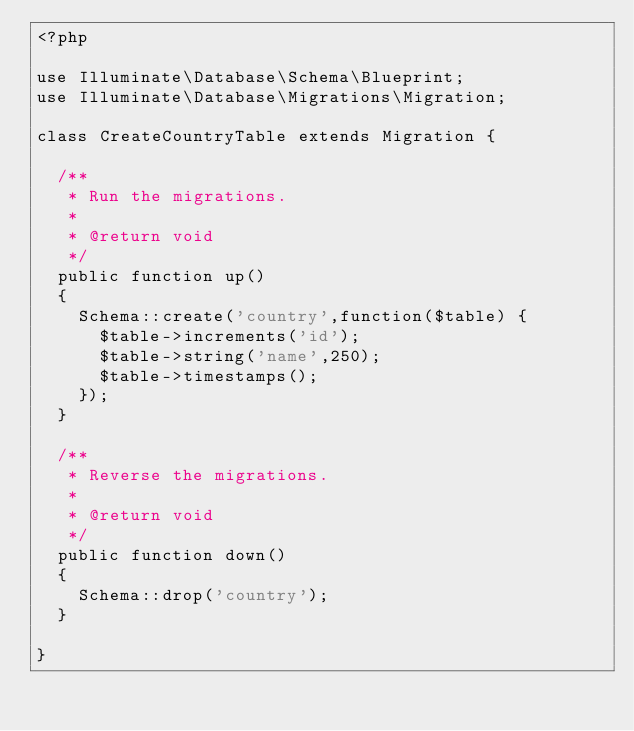Convert code to text. <code><loc_0><loc_0><loc_500><loc_500><_PHP_><?php

use Illuminate\Database\Schema\Blueprint;
use Illuminate\Database\Migrations\Migration;

class CreateCountryTable extends Migration {

	/**
	 * Run the migrations.
	 *
	 * @return void
	 */
	public function up()
	{
		Schema::create('country',function($table) {
			$table->increments('id');
			$table->string('name',250);
			$table->timestamps();
		});
	}

	/**
	 * Reverse the migrations.
	 *
	 * @return void
	 */
	public function down()
	{
		Schema::drop('country');
	}

}
</code> 